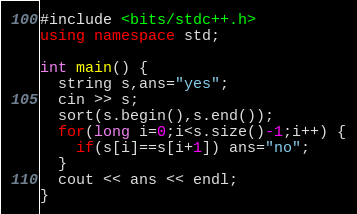Convert code to text. <code><loc_0><loc_0><loc_500><loc_500><_C++_>#include <bits/stdc++.h>
using namespace std;

int main() {
  string s,ans="yes";
  cin >> s;
  sort(s.begin(),s.end());
  for(long i=0;i<s.size()-1;i++) {
    if(s[i]==s[i+1]) ans="no";
  }
  cout << ans << endl;
}</code> 